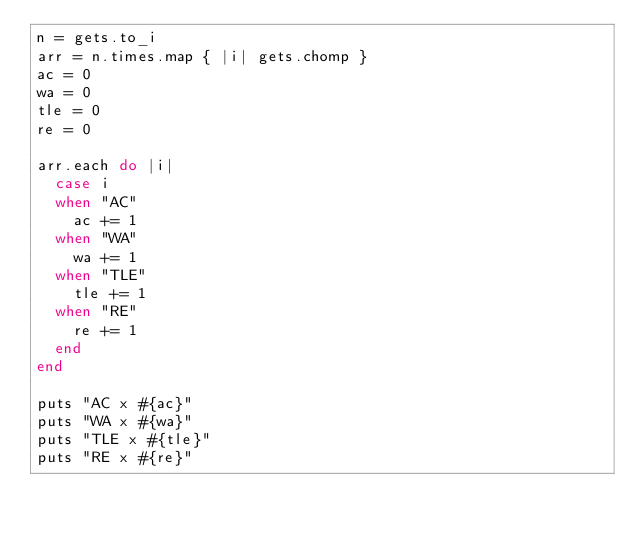Convert code to text. <code><loc_0><loc_0><loc_500><loc_500><_Ruby_>n = gets.to_i
arr = n.times.map { |i| gets.chomp }
ac = 0
wa = 0
tle = 0
re = 0

arr.each do |i|
  case i
  when "AC"
    ac += 1
  when "WA"
    wa += 1
  when "TLE"
    tle += 1
  when "RE"
    re += 1
  end
end

puts "AC x #{ac}"
puts "WA x #{wa}"
puts "TLE x #{tle}"
puts "RE x #{re}"
</code> 